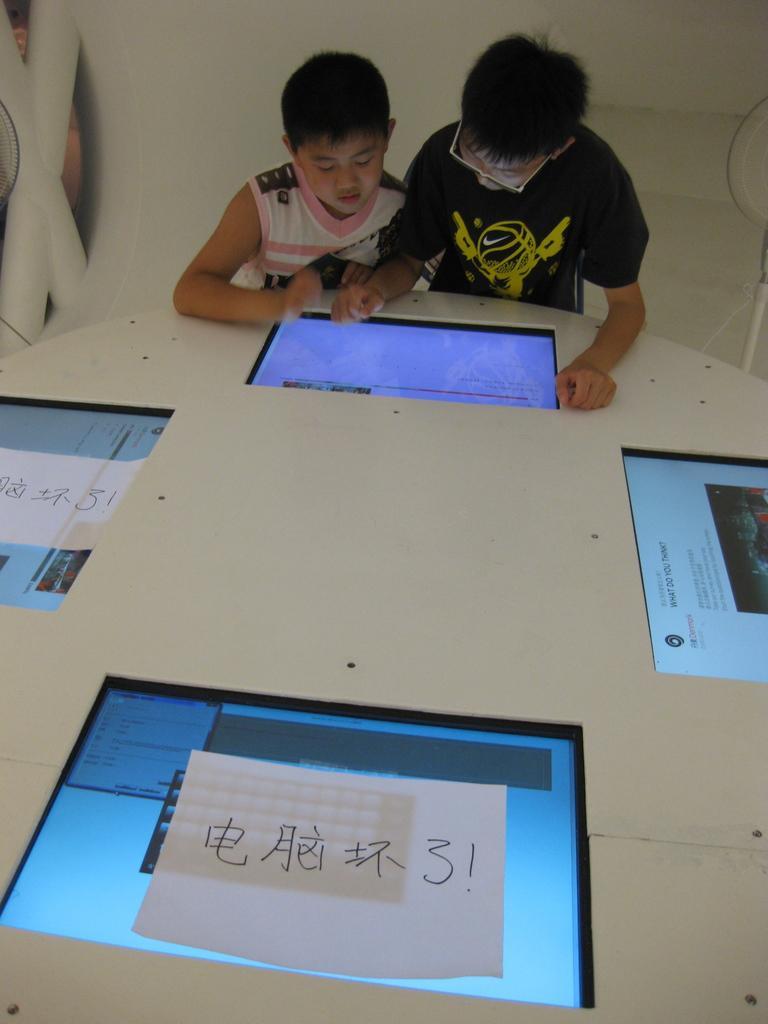How would you summarize this image in a sentence or two? In this picture I can see the table in front and I see 4 screens on it and I see 2 white color papers on 2 screens and I see something is written on the papers. In the background I can see 2 boys standing near to the table and I can see the wall. 